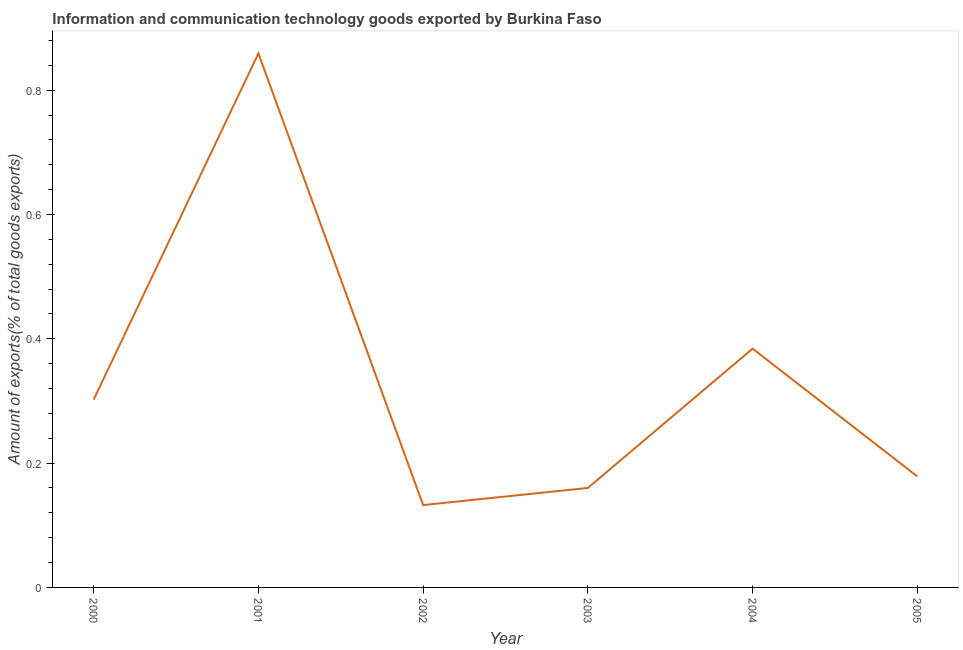What is the amount of ict goods exports in 2005?
Provide a succinct answer. 0.18. Across all years, what is the maximum amount of ict goods exports?
Offer a terse response. 0.86. Across all years, what is the minimum amount of ict goods exports?
Provide a short and direct response. 0.13. In which year was the amount of ict goods exports maximum?
Ensure brevity in your answer.  2001. In which year was the amount of ict goods exports minimum?
Make the answer very short. 2002. What is the sum of the amount of ict goods exports?
Ensure brevity in your answer.  2.02. What is the difference between the amount of ict goods exports in 2000 and 2001?
Give a very brief answer. -0.56. What is the average amount of ict goods exports per year?
Keep it short and to the point. 0.34. What is the median amount of ict goods exports?
Provide a succinct answer. 0.24. What is the ratio of the amount of ict goods exports in 2000 to that in 2004?
Provide a short and direct response. 0.79. Is the amount of ict goods exports in 2001 less than that in 2005?
Offer a terse response. No. What is the difference between the highest and the second highest amount of ict goods exports?
Provide a short and direct response. 0.48. What is the difference between the highest and the lowest amount of ict goods exports?
Offer a terse response. 0.73. In how many years, is the amount of ict goods exports greater than the average amount of ict goods exports taken over all years?
Offer a terse response. 2. Does the amount of ict goods exports monotonically increase over the years?
Ensure brevity in your answer.  No. What is the title of the graph?
Give a very brief answer. Information and communication technology goods exported by Burkina Faso. What is the label or title of the X-axis?
Offer a very short reply. Year. What is the label or title of the Y-axis?
Provide a succinct answer. Amount of exports(% of total goods exports). What is the Amount of exports(% of total goods exports) in 2000?
Ensure brevity in your answer.  0.3. What is the Amount of exports(% of total goods exports) of 2001?
Your response must be concise. 0.86. What is the Amount of exports(% of total goods exports) in 2002?
Provide a succinct answer. 0.13. What is the Amount of exports(% of total goods exports) in 2003?
Keep it short and to the point. 0.16. What is the Amount of exports(% of total goods exports) in 2004?
Keep it short and to the point. 0.38. What is the Amount of exports(% of total goods exports) in 2005?
Ensure brevity in your answer.  0.18. What is the difference between the Amount of exports(% of total goods exports) in 2000 and 2001?
Provide a short and direct response. -0.56. What is the difference between the Amount of exports(% of total goods exports) in 2000 and 2002?
Offer a terse response. 0.17. What is the difference between the Amount of exports(% of total goods exports) in 2000 and 2003?
Your response must be concise. 0.14. What is the difference between the Amount of exports(% of total goods exports) in 2000 and 2004?
Offer a very short reply. -0.08. What is the difference between the Amount of exports(% of total goods exports) in 2000 and 2005?
Provide a succinct answer. 0.12. What is the difference between the Amount of exports(% of total goods exports) in 2001 and 2002?
Provide a short and direct response. 0.73. What is the difference between the Amount of exports(% of total goods exports) in 2001 and 2003?
Offer a very short reply. 0.7. What is the difference between the Amount of exports(% of total goods exports) in 2001 and 2004?
Offer a terse response. 0.48. What is the difference between the Amount of exports(% of total goods exports) in 2001 and 2005?
Your response must be concise. 0.68. What is the difference between the Amount of exports(% of total goods exports) in 2002 and 2003?
Provide a succinct answer. -0.03. What is the difference between the Amount of exports(% of total goods exports) in 2002 and 2004?
Provide a short and direct response. -0.25. What is the difference between the Amount of exports(% of total goods exports) in 2002 and 2005?
Provide a short and direct response. -0.05. What is the difference between the Amount of exports(% of total goods exports) in 2003 and 2004?
Provide a short and direct response. -0.22. What is the difference between the Amount of exports(% of total goods exports) in 2003 and 2005?
Your answer should be compact. -0.02. What is the difference between the Amount of exports(% of total goods exports) in 2004 and 2005?
Ensure brevity in your answer.  0.21. What is the ratio of the Amount of exports(% of total goods exports) in 2000 to that in 2001?
Make the answer very short. 0.35. What is the ratio of the Amount of exports(% of total goods exports) in 2000 to that in 2002?
Ensure brevity in your answer.  2.28. What is the ratio of the Amount of exports(% of total goods exports) in 2000 to that in 2003?
Give a very brief answer. 1.89. What is the ratio of the Amount of exports(% of total goods exports) in 2000 to that in 2004?
Ensure brevity in your answer.  0.79. What is the ratio of the Amount of exports(% of total goods exports) in 2000 to that in 2005?
Offer a very short reply. 1.69. What is the ratio of the Amount of exports(% of total goods exports) in 2001 to that in 2002?
Provide a short and direct response. 6.48. What is the ratio of the Amount of exports(% of total goods exports) in 2001 to that in 2003?
Provide a short and direct response. 5.37. What is the ratio of the Amount of exports(% of total goods exports) in 2001 to that in 2004?
Your response must be concise. 2.24. What is the ratio of the Amount of exports(% of total goods exports) in 2001 to that in 2005?
Ensure brevity in your answer.  4.81. What is the ratio of the Amount of exports(% of total goods exports) in 2002 to that in 2003?
Ensure brevity in your answer.  0.83. What is the ratio of the Amount of exports(% of total goods exports) in 2002 to that in 2004?
Your answer should be very brief. 0.34. What is the ratio of the Amount of exports(% of total goods exports) in 2002 to that in 2005?
Your answer should be very brief. 0.74. What is the ratio of the Amount of exports(% of total goods exports) in 2003 to that in 2004?
Provide a succinct answer. 0.42. What is the ratio of the Amount of exports(% of total goods exports) in 2003 to that in 2005?
Your response must be concise. 0.9. What is the ratio of the Amount of exports(% of total goods exports) in 2004 to that in 2005?
Provide a short and direct response. 2.15. 